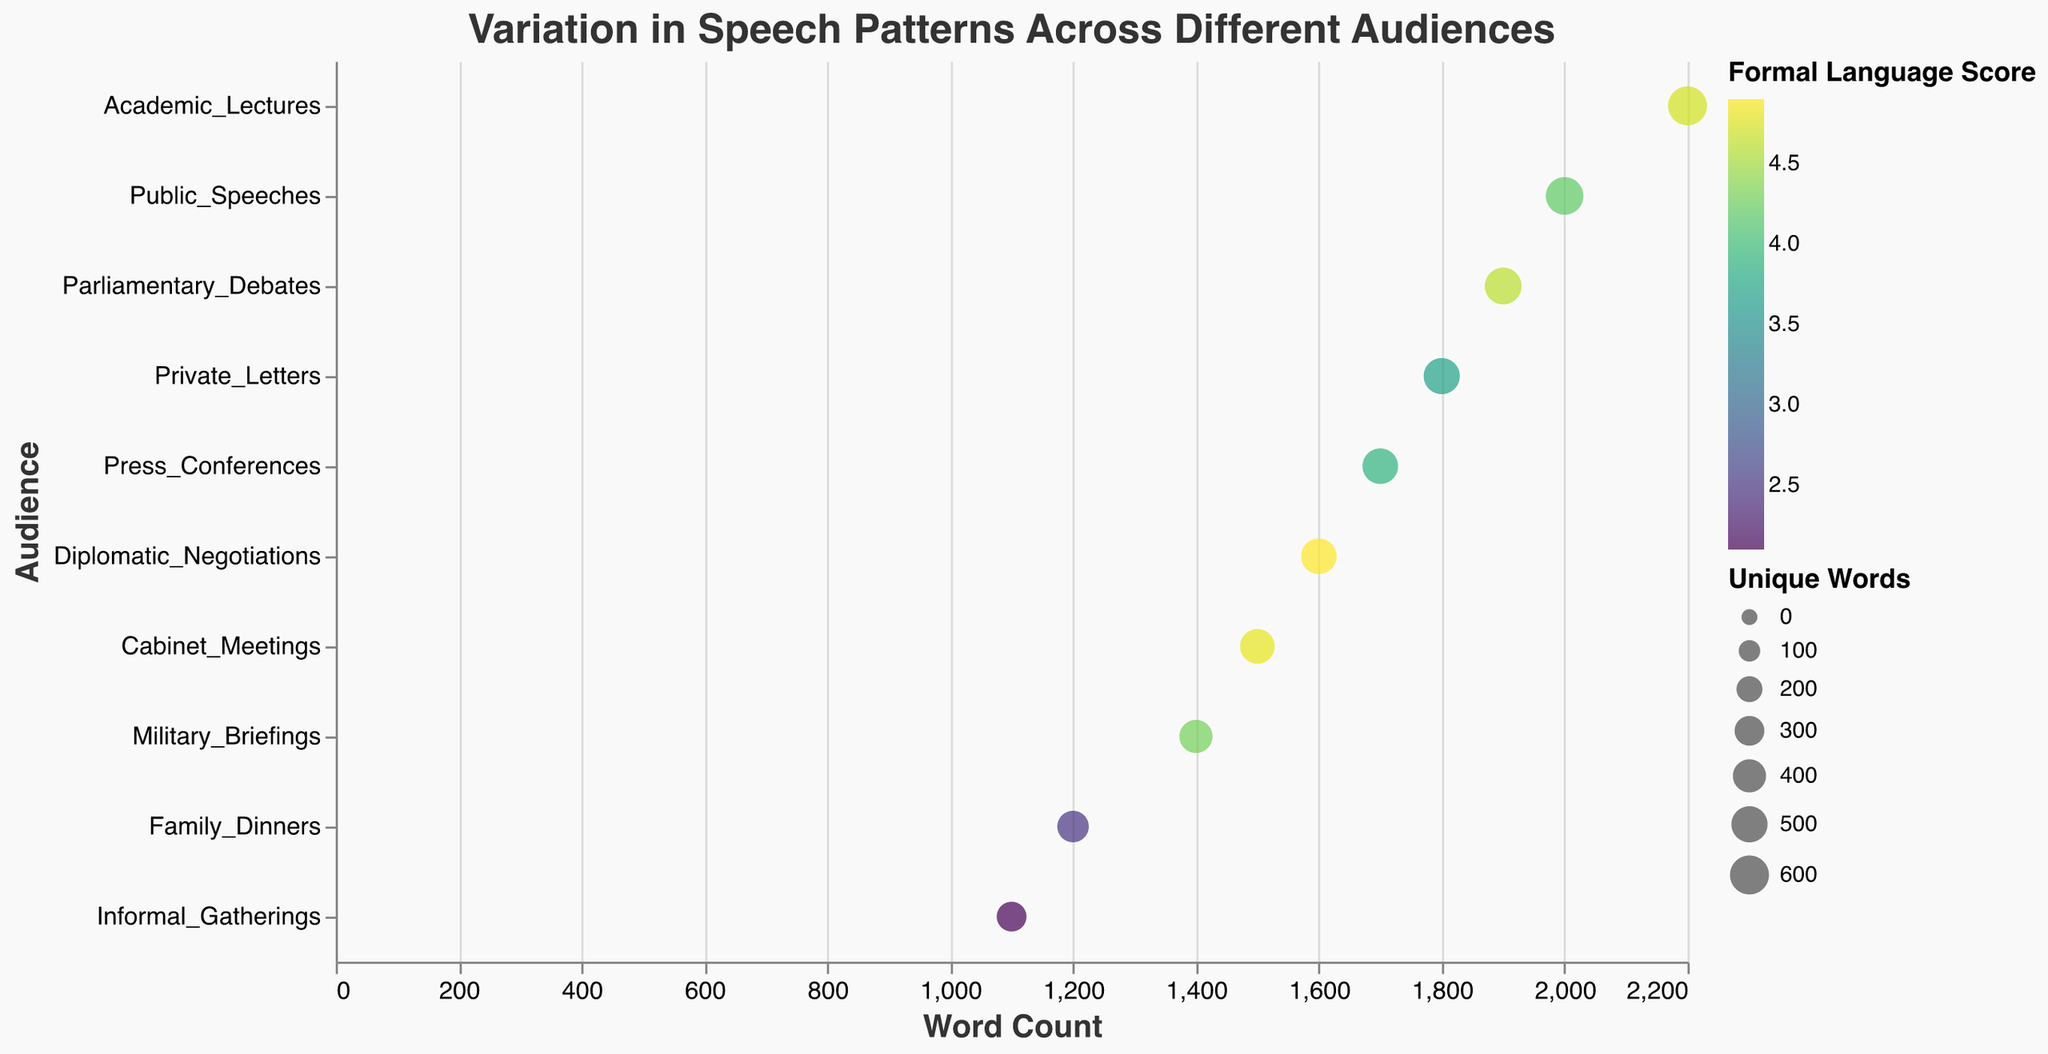What's the title of the figure? The title of the figure is prominently displayed at the top and it reads "Variation in Speech Patterns Across Different Audiences".
Answer: Variation in Speech Patterns Across Different Audiences How many different audiences are represented in the plot? Each point on the y-axis represents a different audience, and by counting them, we find there are ten distinct audiences.
Answer: Ten Which audience has the highest word count in their speech patterns? By looking at the x-axis which represents word count, the point furthest to the right corresponds to "Academic Lectures" with a word count of 2200.
Answer: Academic Lectures Which audience has the lowest formal language score? The color intensity represents the formal language score, and the lightest colored point corresponds to "Informal Gatherings" with a formal language score of 2.1.
Answer: Informal Gatherings For which audience are the unique words the highest? The size of the points represents the number of unique words, and the largest point corresponds to "Academic Lectures" with 600 unique words.
Answer: Academic Lectures What is the average word length for "Private Letters"? Hovering over or consulting the tooltip will show that the average word length for "Private Letters" is 4.5.
Answer: 4.5 Which audience's speech patterns have a lower word count but a higher formal language score than "Press Conferences"? By comparing word count and formal language score visually, "Diplomatic Negotiations" is the audience with a lower word count (1600) but a higher formal language score (4.9) than "Press Conferences" (1700 and 3.9).
Answer: Diplomatic Negotiations Compare the word counts of "Family Dinners" and "Military Briefings". Which has more and by how much? "Family Dinners" has a word count of 1200 and "Military Briefings" has a word count of 1400. By subtracting: 1400 - 1200 = 200. So, "Military Briefings" has 200 more words.
Answer: Military Briefings by 200 What is the relationship between word count and formal language score for "Public Speeches"? "Public Speeches" have a word count of 2000 and a formal language score of 4.2, as shown in the tooltip.
Answer: Word count: 2000, Formal language score: 4.2 Identify the audience with both high formal language scores and a large number of unique words. By looking for points that are both dark-colored (high formal language scores) and large-sized (many unique words), "Academic Lectures" (600 unique words, 4.7 score) fits both criteria.
Answer: Academic Lectures 